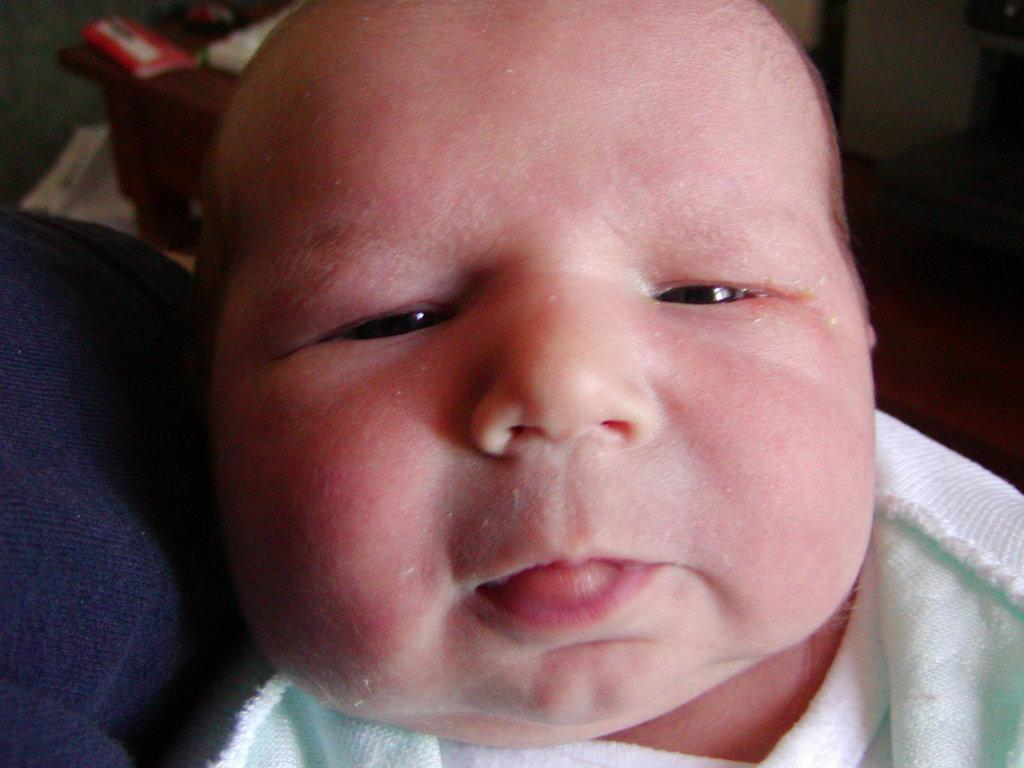What is the main subject in the foreground of the image? There is a baby in the foreground of the image. What can be seen in the background of the image? There are objects in the background of the image. What type of boat is the baby using in the image? There is no boat present in the image; it features a baby in the foreground and objects in the background. 